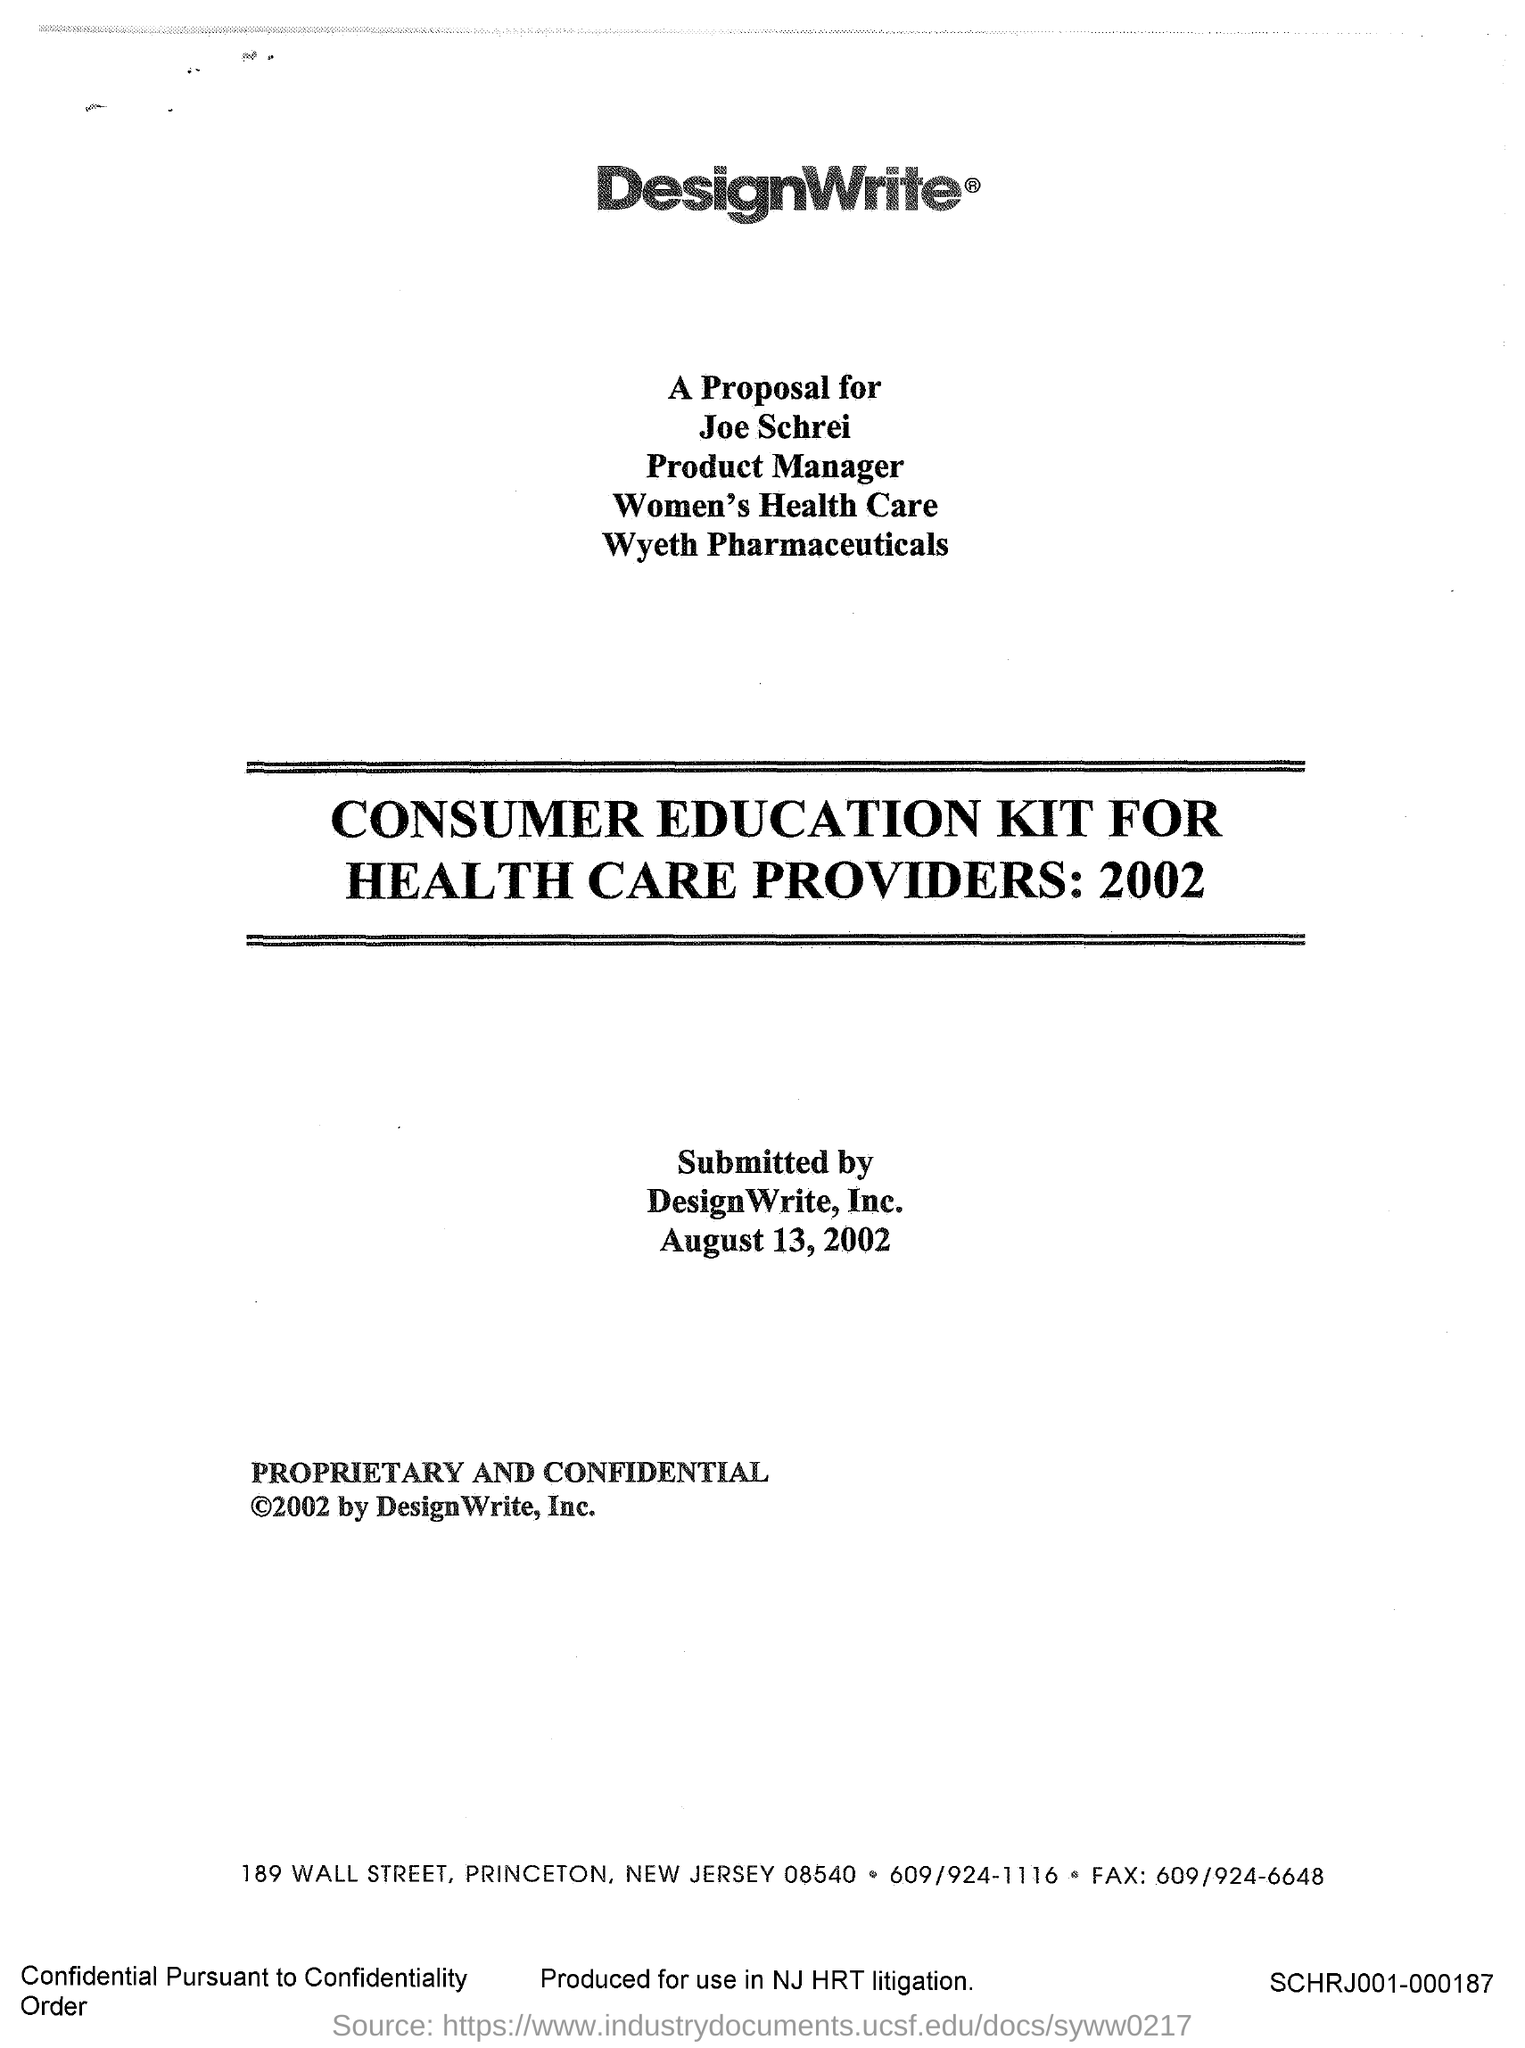What is the company name?
Offer a terse response. DesignWrite. To whom is the proposal for?
Offer a terse response. Joe Schrei. What is the designation of joe schrei?
Keep it short and to the point. PRODUCT MANAGER. Joe Schrei is the product manager for which department?
Give a very brief answer. Women's health care. Joe Schrei works for which Pharmaceutical company?
Offer a terse response. Wyeth Pharmaceuticals. The consumer education kit is for whom?
Your answer should be very brief. Health care providers. What is the year of the Consumer education Kit?
Provide a succinct answer. 2002. On which date the proposal was submitted?
Your answer should be compact. August 13, 2002. What is the street address of DesignWrite?
Your response must be concise. 189 Wall street. 